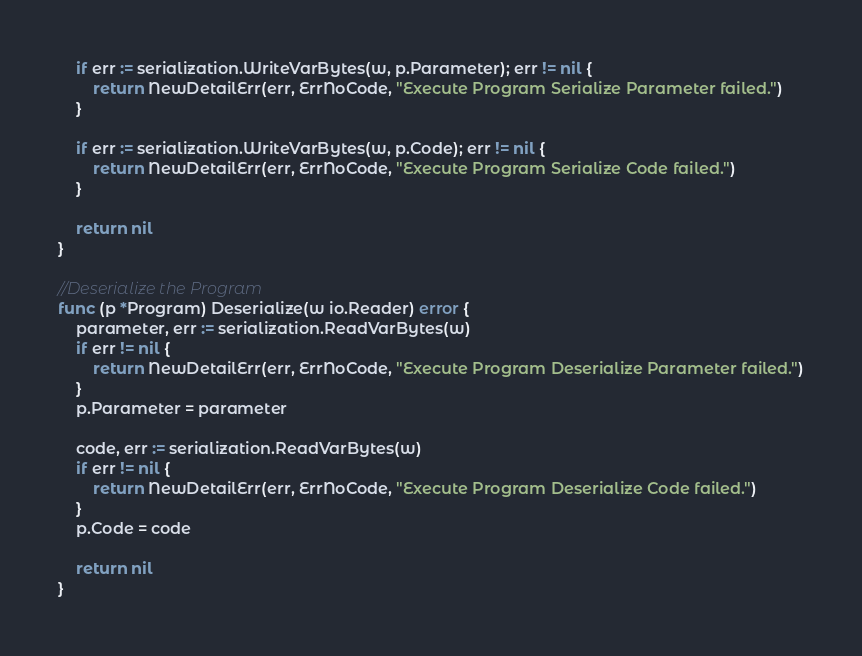Convert code to text. <code><loc_0><loc_0><loc_500><loc_500><_Go_>	if err := serialization.WriteVarBytes(w, p.Parameter); err != nil {
		return NewDetailErr(err, ErrNoCode, "Execute Program Serialize Parameter failed.")
	}

	if err := serialization.WriteVarBytes(w, p.Code); err != nil {
		return NewDetailErr(err, ErrNoCode, "Execute Program Serialize Code failed.")
	}

	return nil
}

//Deserialize the Program
func (p *Program) Deserialize(w io.Reader) error {
	parameter, err := serialization.ReadVarBytes(w)
	if err != nil {
		return NewDetailErr(err, ErrNoCode, "Execute Program Deserialize Parameter failed.")
	}
	p.Parameter = parameter

	code, err := serialization.ReadVarBytes(w)
	if err != nil {
		return NewDetailErr(err, ErrNoCode, "Execute Program Deserialize Code failed.")
	}
	p.Code = code

	return nil
}
</code> 